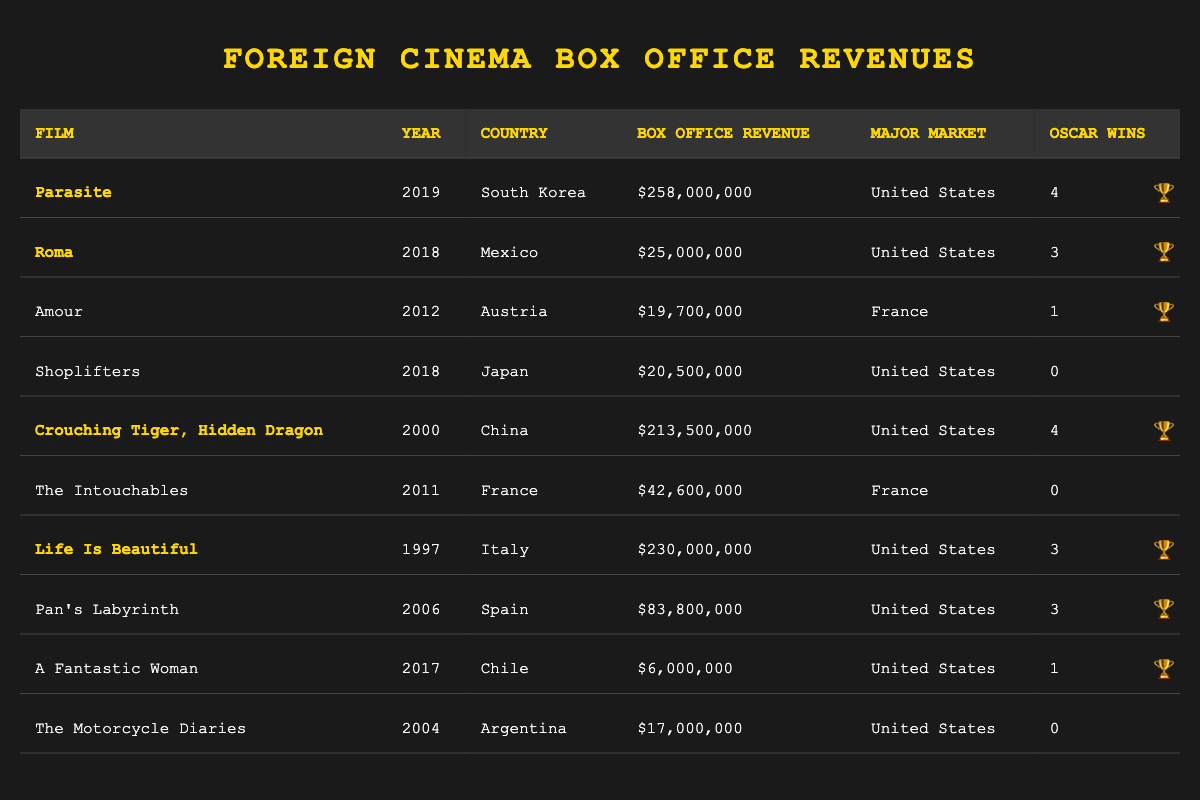What is the box office revenue of "Parasite"? In the table, "Parasite" has a box office revenue value listed as $258,000,000.
Answer: $258,000,000 Which country produced the film "Roma"? The table lists "Roma" under the row where it shows the country is Mexico.
Answer: Mexico How many Oscar wins did "Crouching Tiger, Hidden Dragon" have? The table shows that "Crouching Tiger, Hidden Dragon" has 4 Oscar wins.
Answer: 4 What film has the highest box office revenue? By comparing all the box office revenue figures in the table, "Parasite" has the highest revenue listed at $258,000,000.
Answer: Parasite Which film from Japan earned $20,500,000? The table indicates that "Shoplifters" is the Japanese film that earned $20,500,000 based on the revenue listed.
Answer: Shoplifters How many total Oscar wins do the films from France have? The films from France listed are "Amour," "The Intouchables," and "Pan's Labyrinth," which have 1, 0, and 3 Oscar wins, respectively. Adding these gives a total of 4 Oscar wins.
Answer: 4 Is "Life Is Beautiful" the only Italian film listed in the table? Looking at the table, "Life Is Beautiful" is the only Italian film mentioned, confirming the statement is true.
Answer: Yes What is the total box office revenue for films from the United States listed in the table? The films from the United States are "Parasite," "Roma," "Shoplifters," "Crouching Tiger, Hidden Dragon," "Life Is Beautiful," "Pan's Labyrinth," "A Fantastic Woman," and "The Motorcycle Diaries." Adding their revenues ($258,000,000 + $25,000,000 + $20,500,000 + $213,500,000 + $230,000,000 + $83,800,000 + $6,000,000 + $17,000,000) gives a total of $853,800,000.
Answer: $853,800,000 What is the average box office revenue of the films listed in the table? To find the average, we first calculate the total revenue: $258,000,000 + $25,000,000 + $19,700,000 + $20,500,000 + $213,500,000 + $42,600,000 + $230,000,000 + $83,800,000 + $6,000,000 + $17,000,000 = $615,100,000. There are 10 films, so the average is $615,100,000 / 10 = $61,510,000.
Answer: $61,510,000 Which film had the least box office revenue and how much was it? The film with the least box office revenue in the table is "A Fantastic Woman," which earned $6,000,000.
Answer: A Fantastic Woman, $6,000,000 